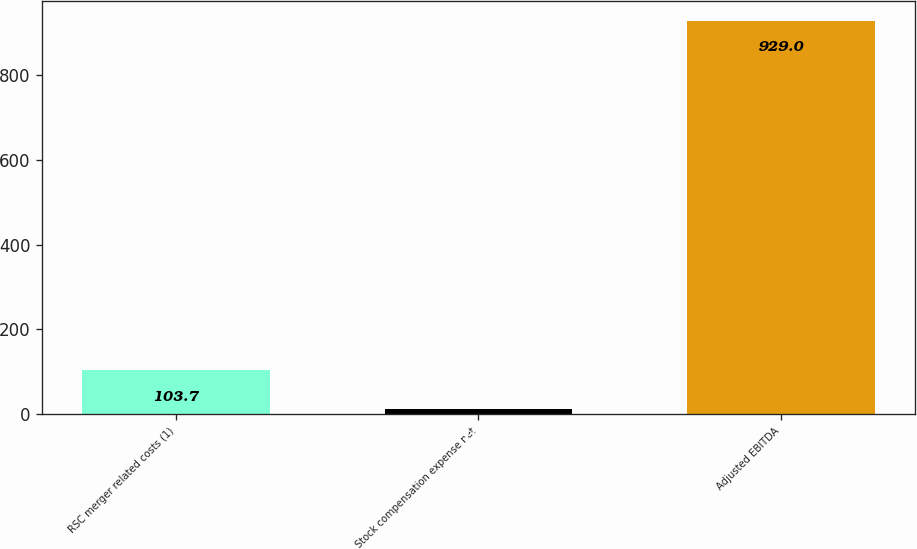Convert chart to OTSL. <chart><loc_0><loc_0><loc_500><loc_500><bar_chart><fcel>RSC merger related costs (1)<fcel>Stock compensation expense net<fcel>Adjusted EBITDA<nl><fcel>103.7<fcel>12<fcel>929<nl></chart> 